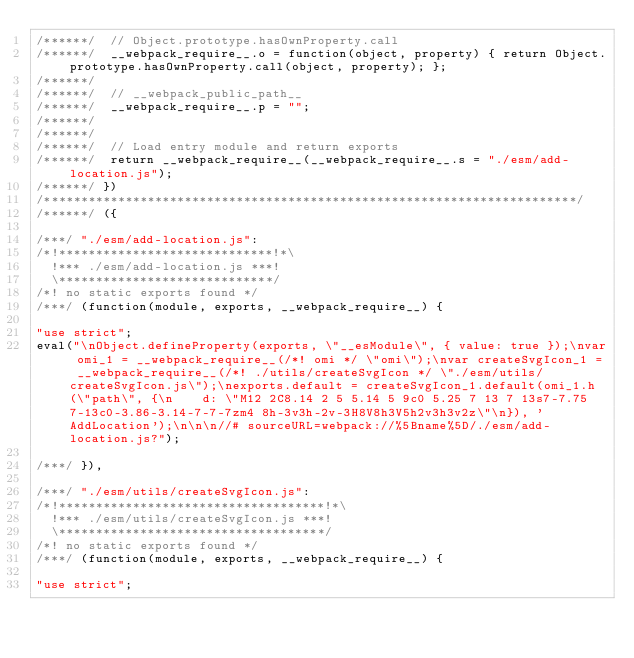Convert code to text. <code><loc_0><loc_0><loc_500><loc_500><_JavaScript_>/******/ 	// Object.prototype.hasOwnProperty.call
/******/ 	__webpack_require__.o = function(object, property) { return Object.prototype.hasOwnProperty.call(object, property); };
/******/
/******/ 	// __webpack_public_path__
/******/ 	__webpack_require__.p = "";
/******/
/******/
/******/ 	// Load entry module and return exports
/******/ 	return __webpack_require__(__webpack_require__.s = "./esm/add-location.js");
/******/ })
/************************************************************************/
/******/ ({

/***/ "./esm/add-location.js":
/*!*****************************!*\
  !*** ./esm/add-location.js ***!
  \*****************************/
/*! no static exports found */
/***/ (function(module, exports, __webpack_require__) {

"use strict";
eval("\nObject.defineProperty(exports, \"__esModule\", { value: true });\nvar omi_1 = __webpack_require__(/*! omi */ \"omi\");\nvar createSvgIcon_1 = __webpack_require__(/*! ./utils/createSvgIcon */ \"./esm/utils/createSvgIcon.js\");\nexports.default = createSvgIcon_1.default(omi_1.h(\"path\", {\n    d: \"M12 2C8.14 2 5 5.14 5 9c0 5.25 7 13 7 13s7-7.75 7-13c0-3.86-3.14-7-7-7zm4 8h-3v3h-2v-3H8V8h3V5h2v3h3v2z\"\n}), 'AddLocation');\n\n\n//# sourceURL=webpack://%5Bname%5D/./esm/add-location.js?");

/***/ }),

/***/ "./esm/utils/createSvgIcon.js":
/*!************************************!*\
  !*** ./esm/utils/createSvgIcon.js ***!
  \************************************/
/*! no static exports found */
/***/ (function(module, exports, __webpack_require__) {

"use strict";</code> 